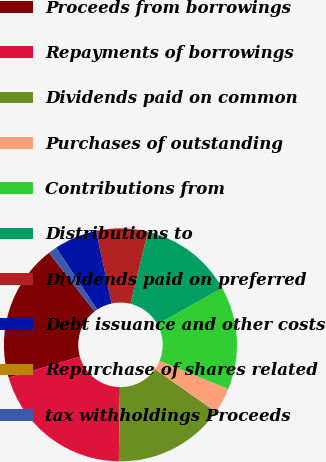Convert chart to OTSL. <chart><loc_0><loc_0><loc_500><loc_500><pie_chart><fcel>Proceeds from borrowings<fcel>Repayments of borrowings<fcel>Dividends paid on common<fcel>Purchases of outstanding<fcel>Contributions from<fcel>Distributions to<fcel>Dividends paid on preferred<fcel>Debt issuance and other costs<fcel>Repurchase of shares related<fcel>tax withholdings Proceeds<nl><fcel>19.04%<fcel>20.23%<fcel>15.47%<fcel>3.57%<fcel>14.28%<fcel>13.09%<fcel>7.14%<fcel>5.95%<fcel>0.0%<fcel>1.19%<nl></chart> 